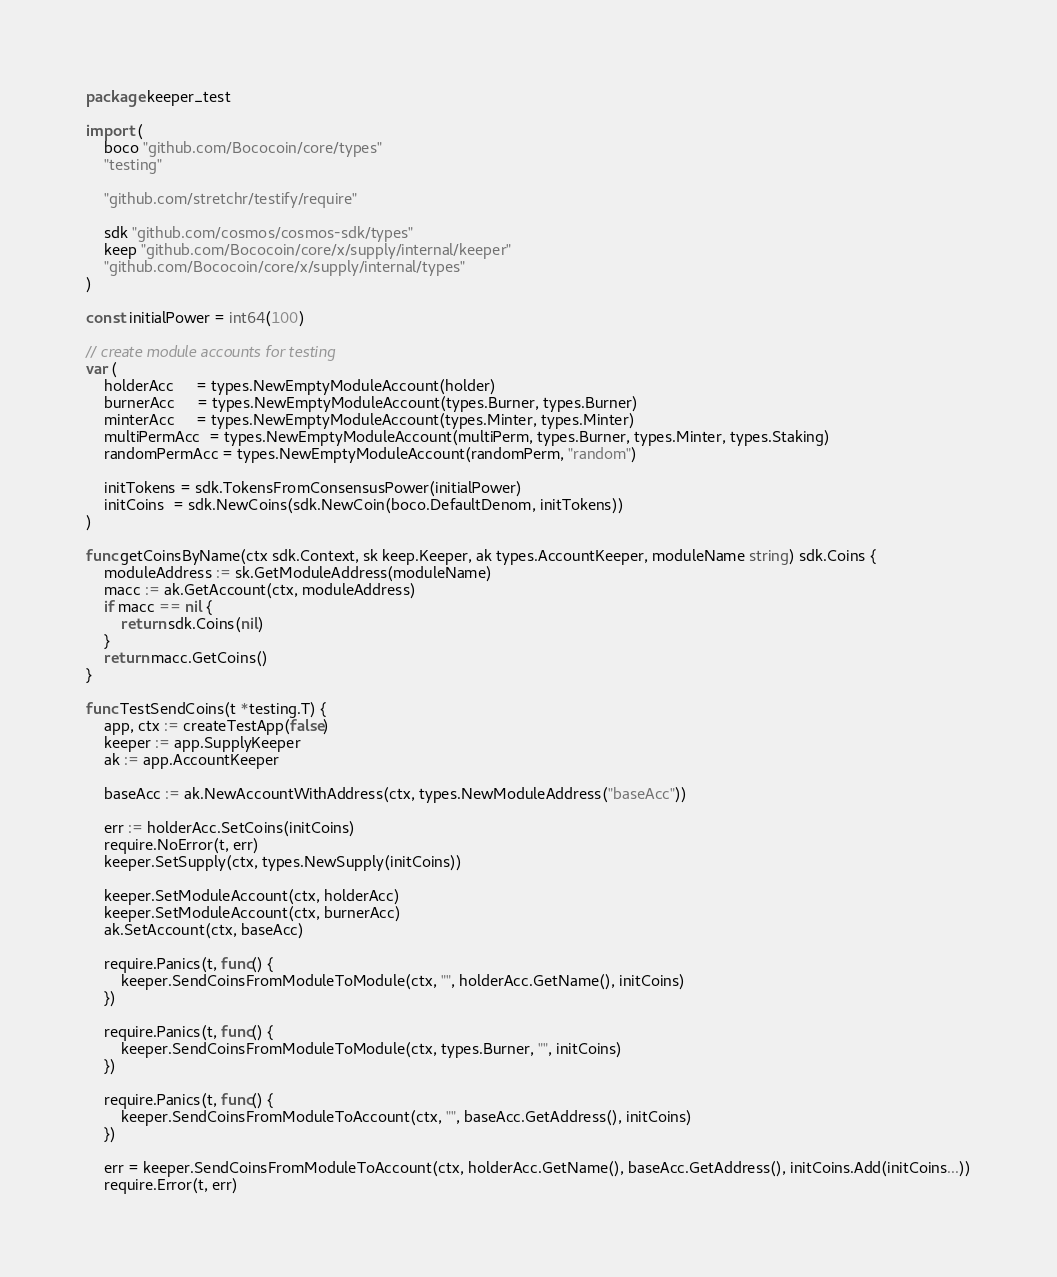<code> <loc_0><loc_0><loc_500><loc_500><_Go_>package keeper_test

import (
	boco "github.com/Bococoin/core/types"
	"testing"

	"github.com/stretchr/testify/require"

	sdk "github.com/cosmos/cosmos-sdk/types"
	keep "github.com/Bococoin/core/x/supply/internal/keeper"
	"github.com/Bococoin/core/x/supply/internal/types"
)

const initialPower = int64(100)

// create module accounts for testing
var (
	holderAcc     = types.NewEmptyModuleAccount(holder)
	burnerAcc     = types.NewEmptyModuleAccount(types.Burner, types.Burner)
	minterAcc     = types.NewEmptyModuleAccount(types.Minter, types.Minter)
	multiPermAcc  = types.NewEmptyModuleAccount(multiPerm, types.Burner, types.Minter, types.Staking)
	randomPermAcc = types.NewEmptyModuleAccount(randomPerm, "random")

	initTokens = sdk.TokensFromConsensusPower(initialPower)
	initCoins  = sdk.NewCoins(sdk.NewCoin(boco.DefaultDenom, initTokens))
)

func getCoinsByName(ctx sdk.Context, sk keep.Keeper, ak types.AccountKeeper, moduleName string) sdk.Coins {
	moduleAddress := sk.GetModuleAddress(moduleName)
	macc := ak.GetAccount(ctx, moduleAddress)
	if macc == nil {
		return sdk.Coins(nil)
	}
	return macc.GetCoins()
}

func TestSendCoins(t *testing.T) {
	app, ctx := createTestApp(false)
	keeper := app.SupplyKeeper
	ak := app.AccountKeeper

	baseAcc := ak.NewAccountWithAddress(ctx, types.NewModuleAddress("baseAcc"))

	err := holderAcc.SetCoins(initCoins)
	require.NoError(t, err)
	keeper.SetSupply(ctx, types.NewSupply(initCoins))

	keeper.SetModuleAccount(ctx, holderAcc)
	keeper.SetModuleAccount(ctx, burnerAcc)
	ak.SetAccount(ctx, baseAcc)

	require.Panics(t, func() {
		keeper.SendCoinsFromModuleToModule(ctx, "", holderAcc.GetName(), initCoins)
	})

	require.Panics(t, func() {
		keeper.SendCoinsFromModuleToModule(ctx, types.Burner, "", initCoins)
	})

	require.Panics(t, func() {
		keeper.SendCoinsFromModuleToAccount(ctx, "", baseAcc.GetAddress(), initCoins)
	})

	err = keeper.SendCoinsFromModuleToAccount(ctx, holderAcc.GetName(), baseAcc.GetAddress(), initCoins.Add(initCoins...))
	require.Error(t, err)
</code> 